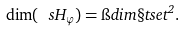Convert formula to latex. <formula><loc_0><loc_0><loc_500><loc_500>\dim ( \ s H _ { \varphi } ) = \i d i m { \S t s e t } ^ { 2 } .</formula> 